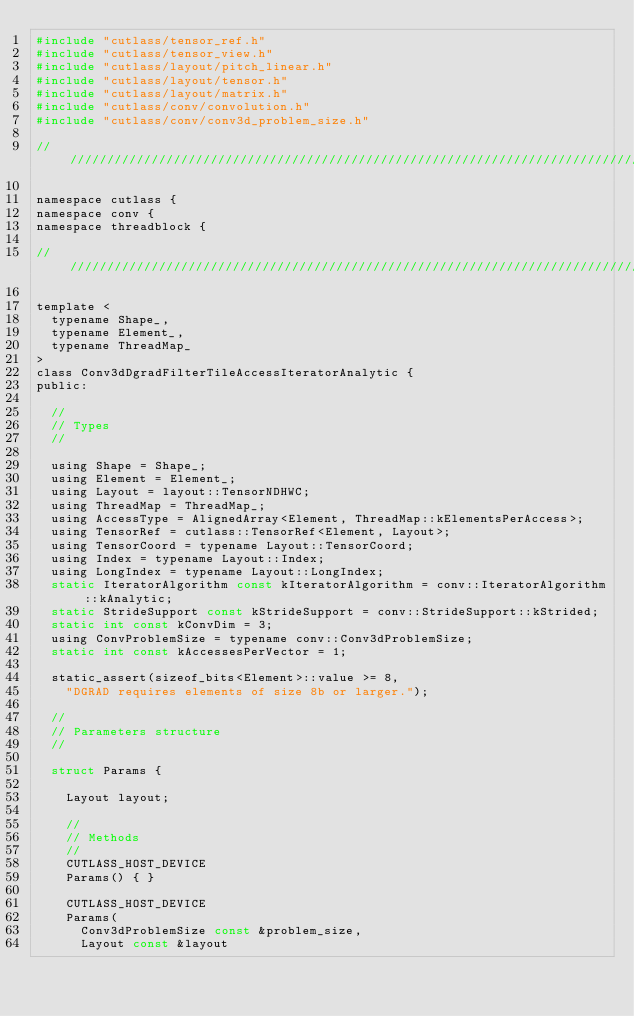<code> <loc_0><loc_0><loc_500><loc_500><_C_>#include "cutlass/tensor_ref.h"
#include "cutlass/tensor_view.h"
#include "cutlass/layout/pitch_linear.h"
#include "cutlass/layout/tensor.h"
#include "cutlass/layout/matrix.h"
#include "cutlass/conv/convolution.h"
#include "cutlass/conv/conv3d_problem_size.h"

/////////////////////////////////////////////////////////////////////////////////////////////////

namespace cutlass {
namespace conv {
namespace threadblock {

/////////////////////////////////////////////////////////////////////////////////////////////////

template <
  typename Shape_,
  typename Element_,
  typename ThreadMap_
>
class Conv3dDgradFilterTileAccessIteratorAnalytic {
public:
  
  //
  // Types
  //

  using Shape = Shape_;
  using Element = Element_;
  using Layout = layout::TensorNDHWC;
  using ThreadMap = ThreadMap_;
  using AccessType = AlignedArray<Element, ThreadMap::kElementsPerAccess>;
  using TensorRef = cutlass::TensorRef<Element, Layout>;
  using TensorCoord = typename Layout::TensorCoord;
  using Index = typename Layout::Index;
  using LongIndex = typename Layout::LongIndex;
  static IteratorAlgorithm const kIteratorAlgorithm = conv::IteratorAlgorithm::kAnalytic;
  static StrideSupport const kStrideSupport = conv::StrideSupport::kStrided;
  static int const kConvDim = 3;
  using ConvProblemSize = typename conv::Conv3dProblemSize;
  static int const kAccessesPerVector = 1;
  
  static_assert(sizeof_bits<Element>::value >= 8, 
    "DGRAD requires elements of size 8b or larger.");
  
  //
  // Parameters structure
  //

  struct Params {

    Layout layout;

    //
    // Methods
    //
    CUTLASS_HOST_DEVICE
    Params() { }

    CUTLASS_HOST_DEVICE
    Params(
      Conv3dProblemSize const &problem_size, 
      Layout const &layout</code> 